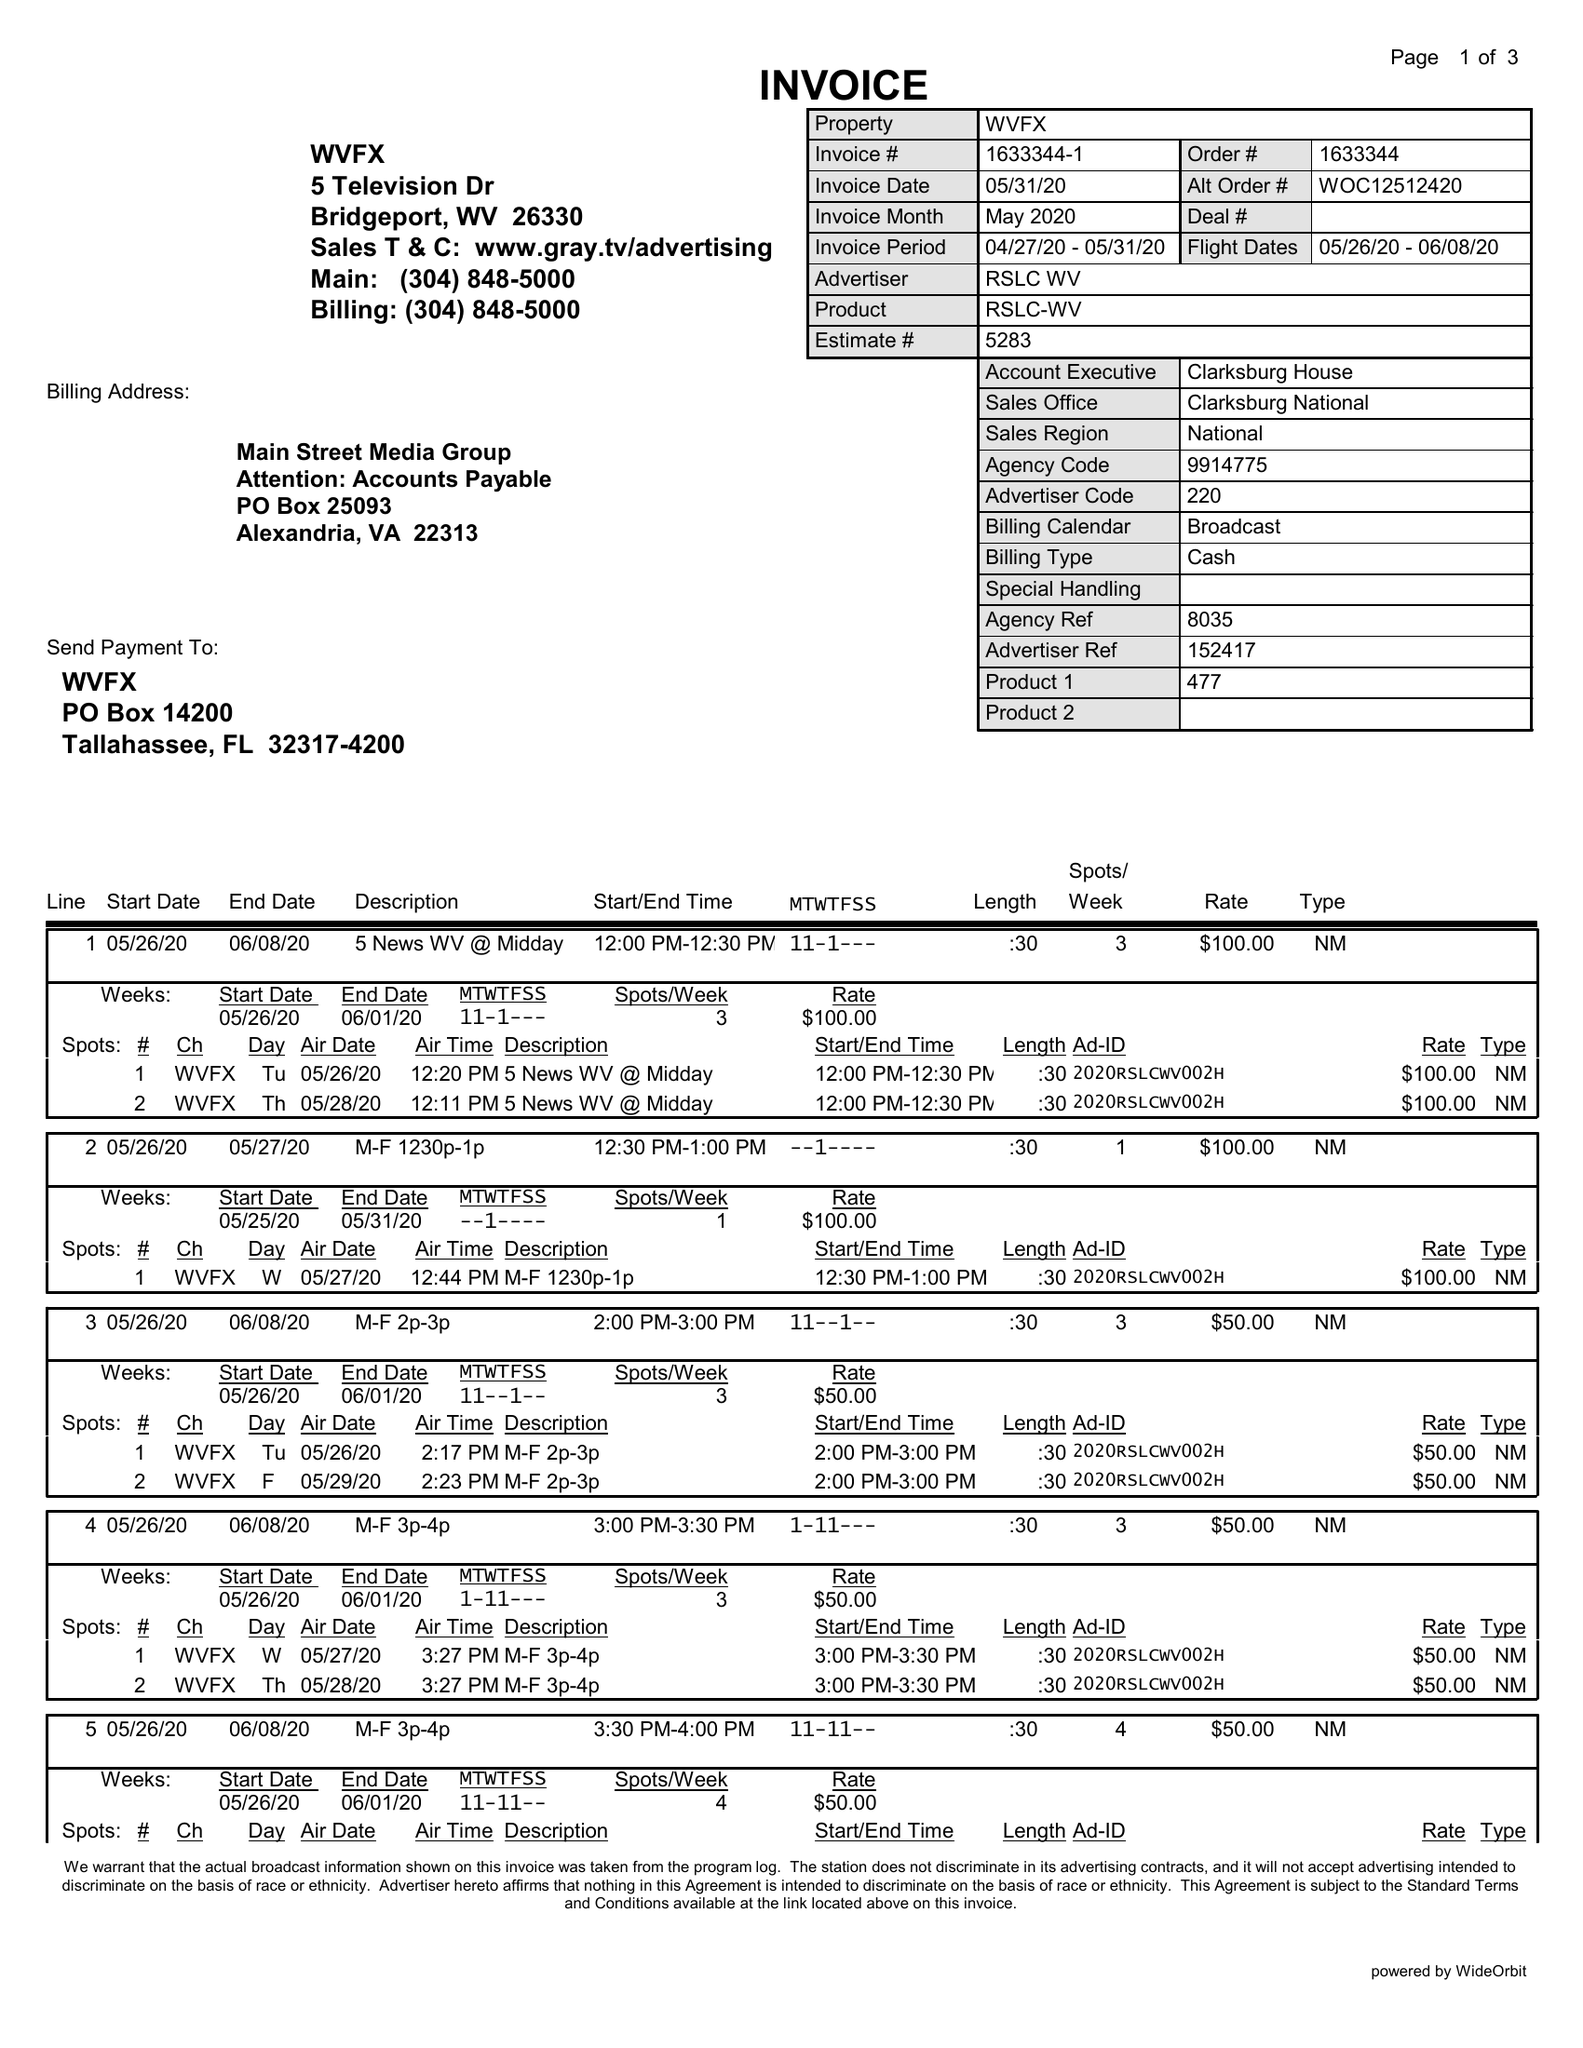What is the value for the flight_from?
Answer the question using a single word or phrase. 05/26/20 